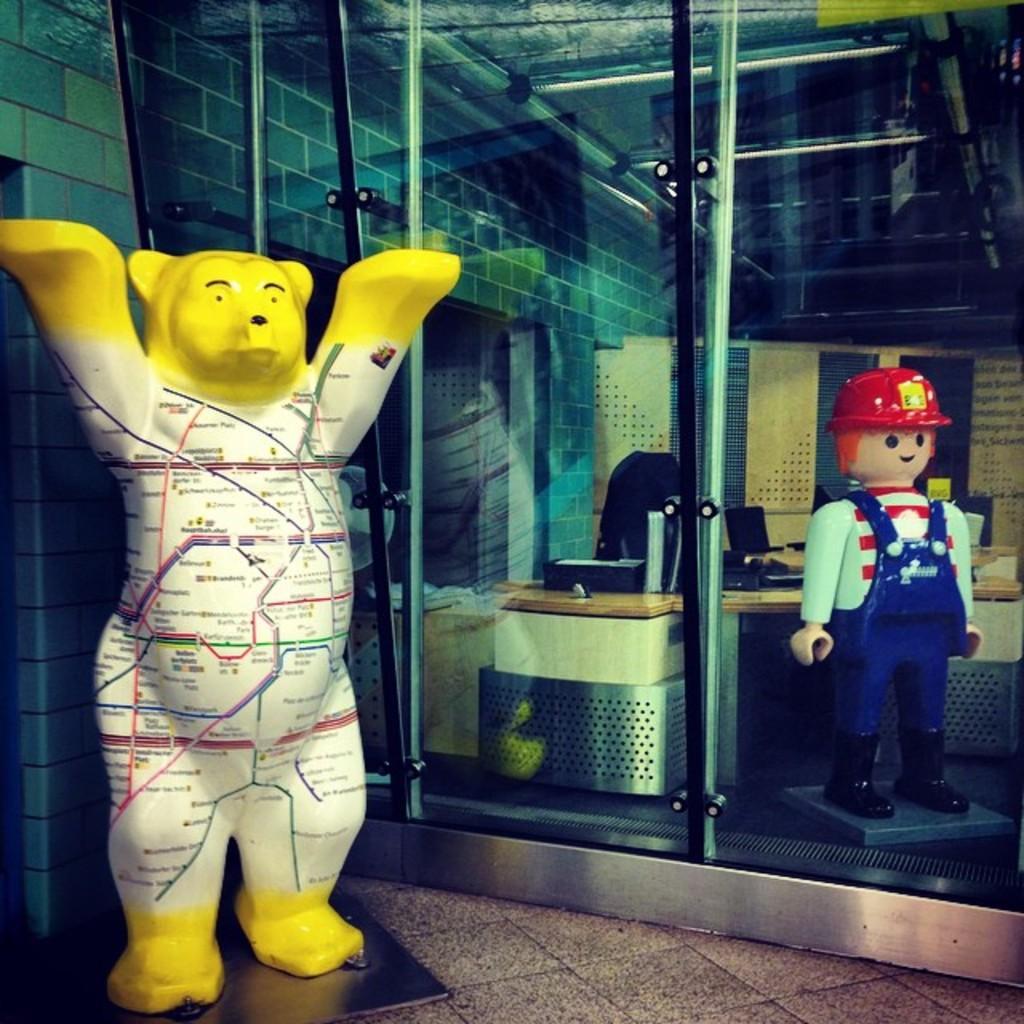How would you summarize this image in a sentence or two? In this image we can see the depictions of a bear and also the person wearing the helmet. We can also see the glass windows and through the glass windows we can see the tables with some objects and also chairs and wall and also the ceiling. We can also see the floor at the bottom. 